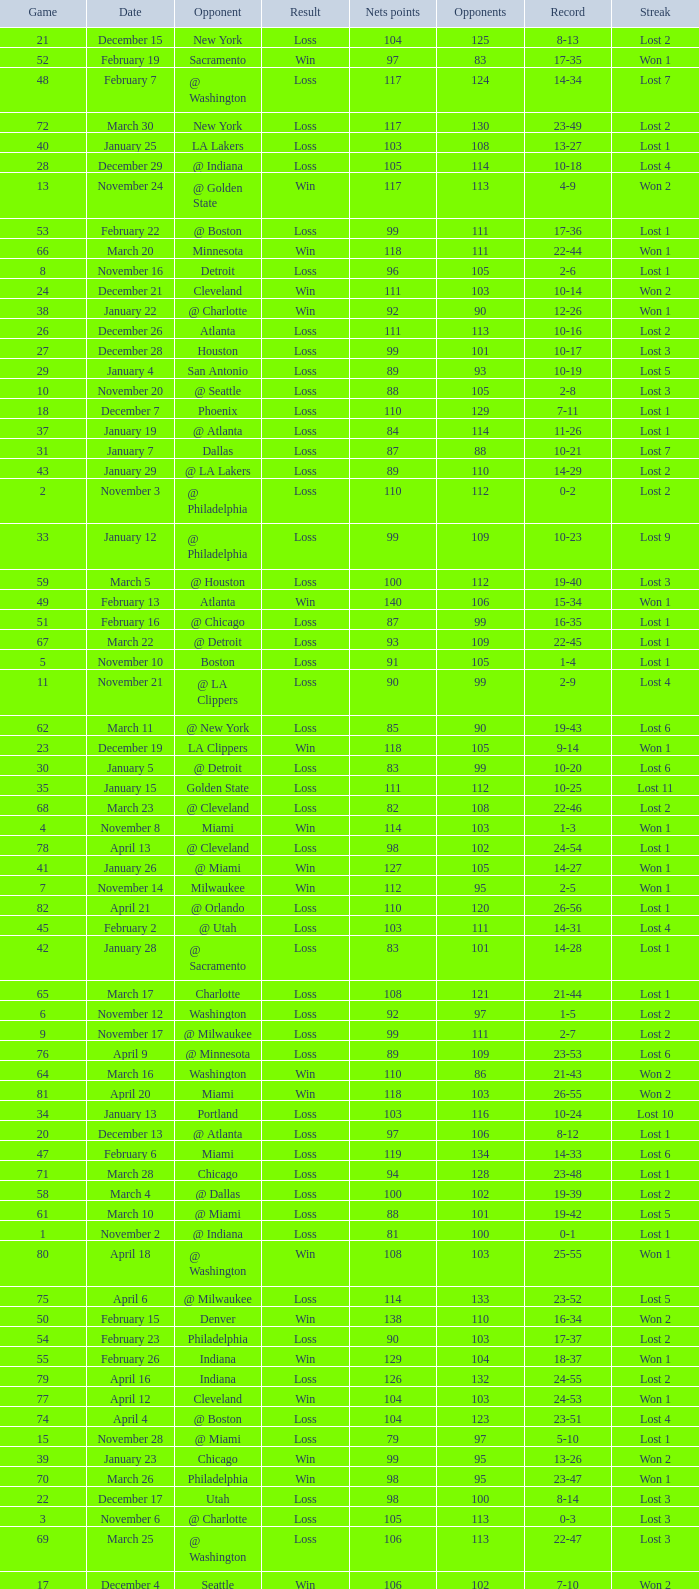What was the average point total for the nets in games before game 9 where the opponents scored less than 95? None. 